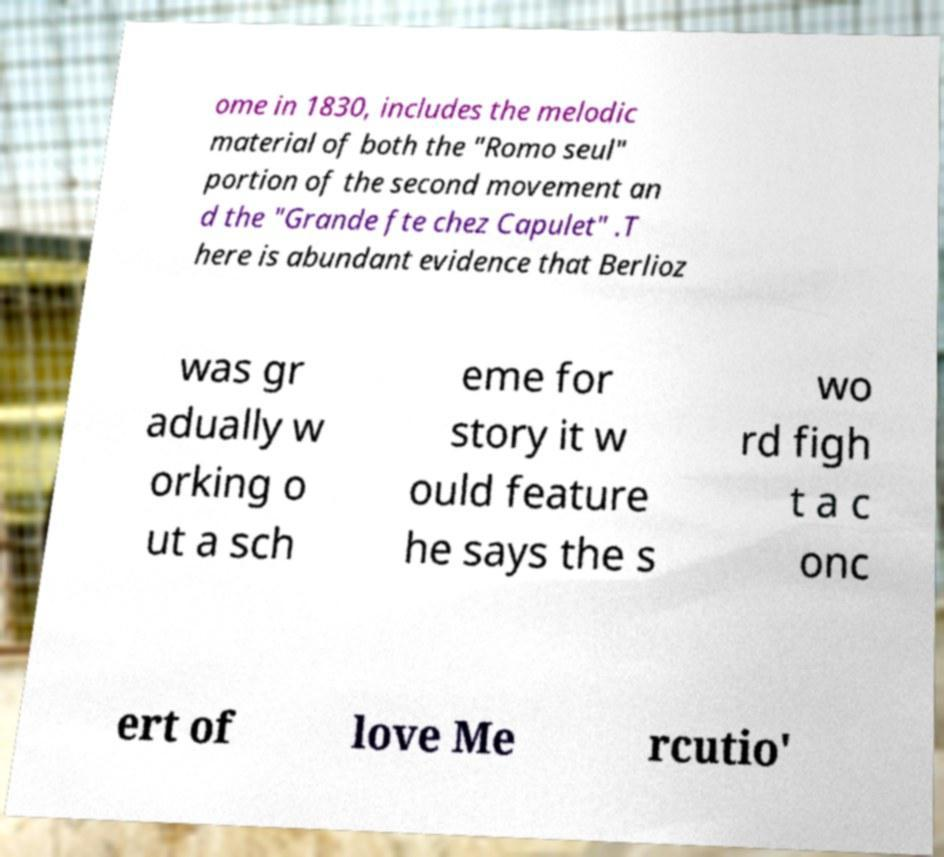For documentation purposes, I need the text within this image transcribed. Could you provide that? ome in 1830, includes the melodic material of both the "Romo seul" portion of the second movement an d the "Grande fte chez Capulet" .T here is abundant evidence that Berlioz was gr adually w orking o ut a sch eme for story it w ould feature he says the s wo rd figh t a c onc ert of love Me rcutio' 